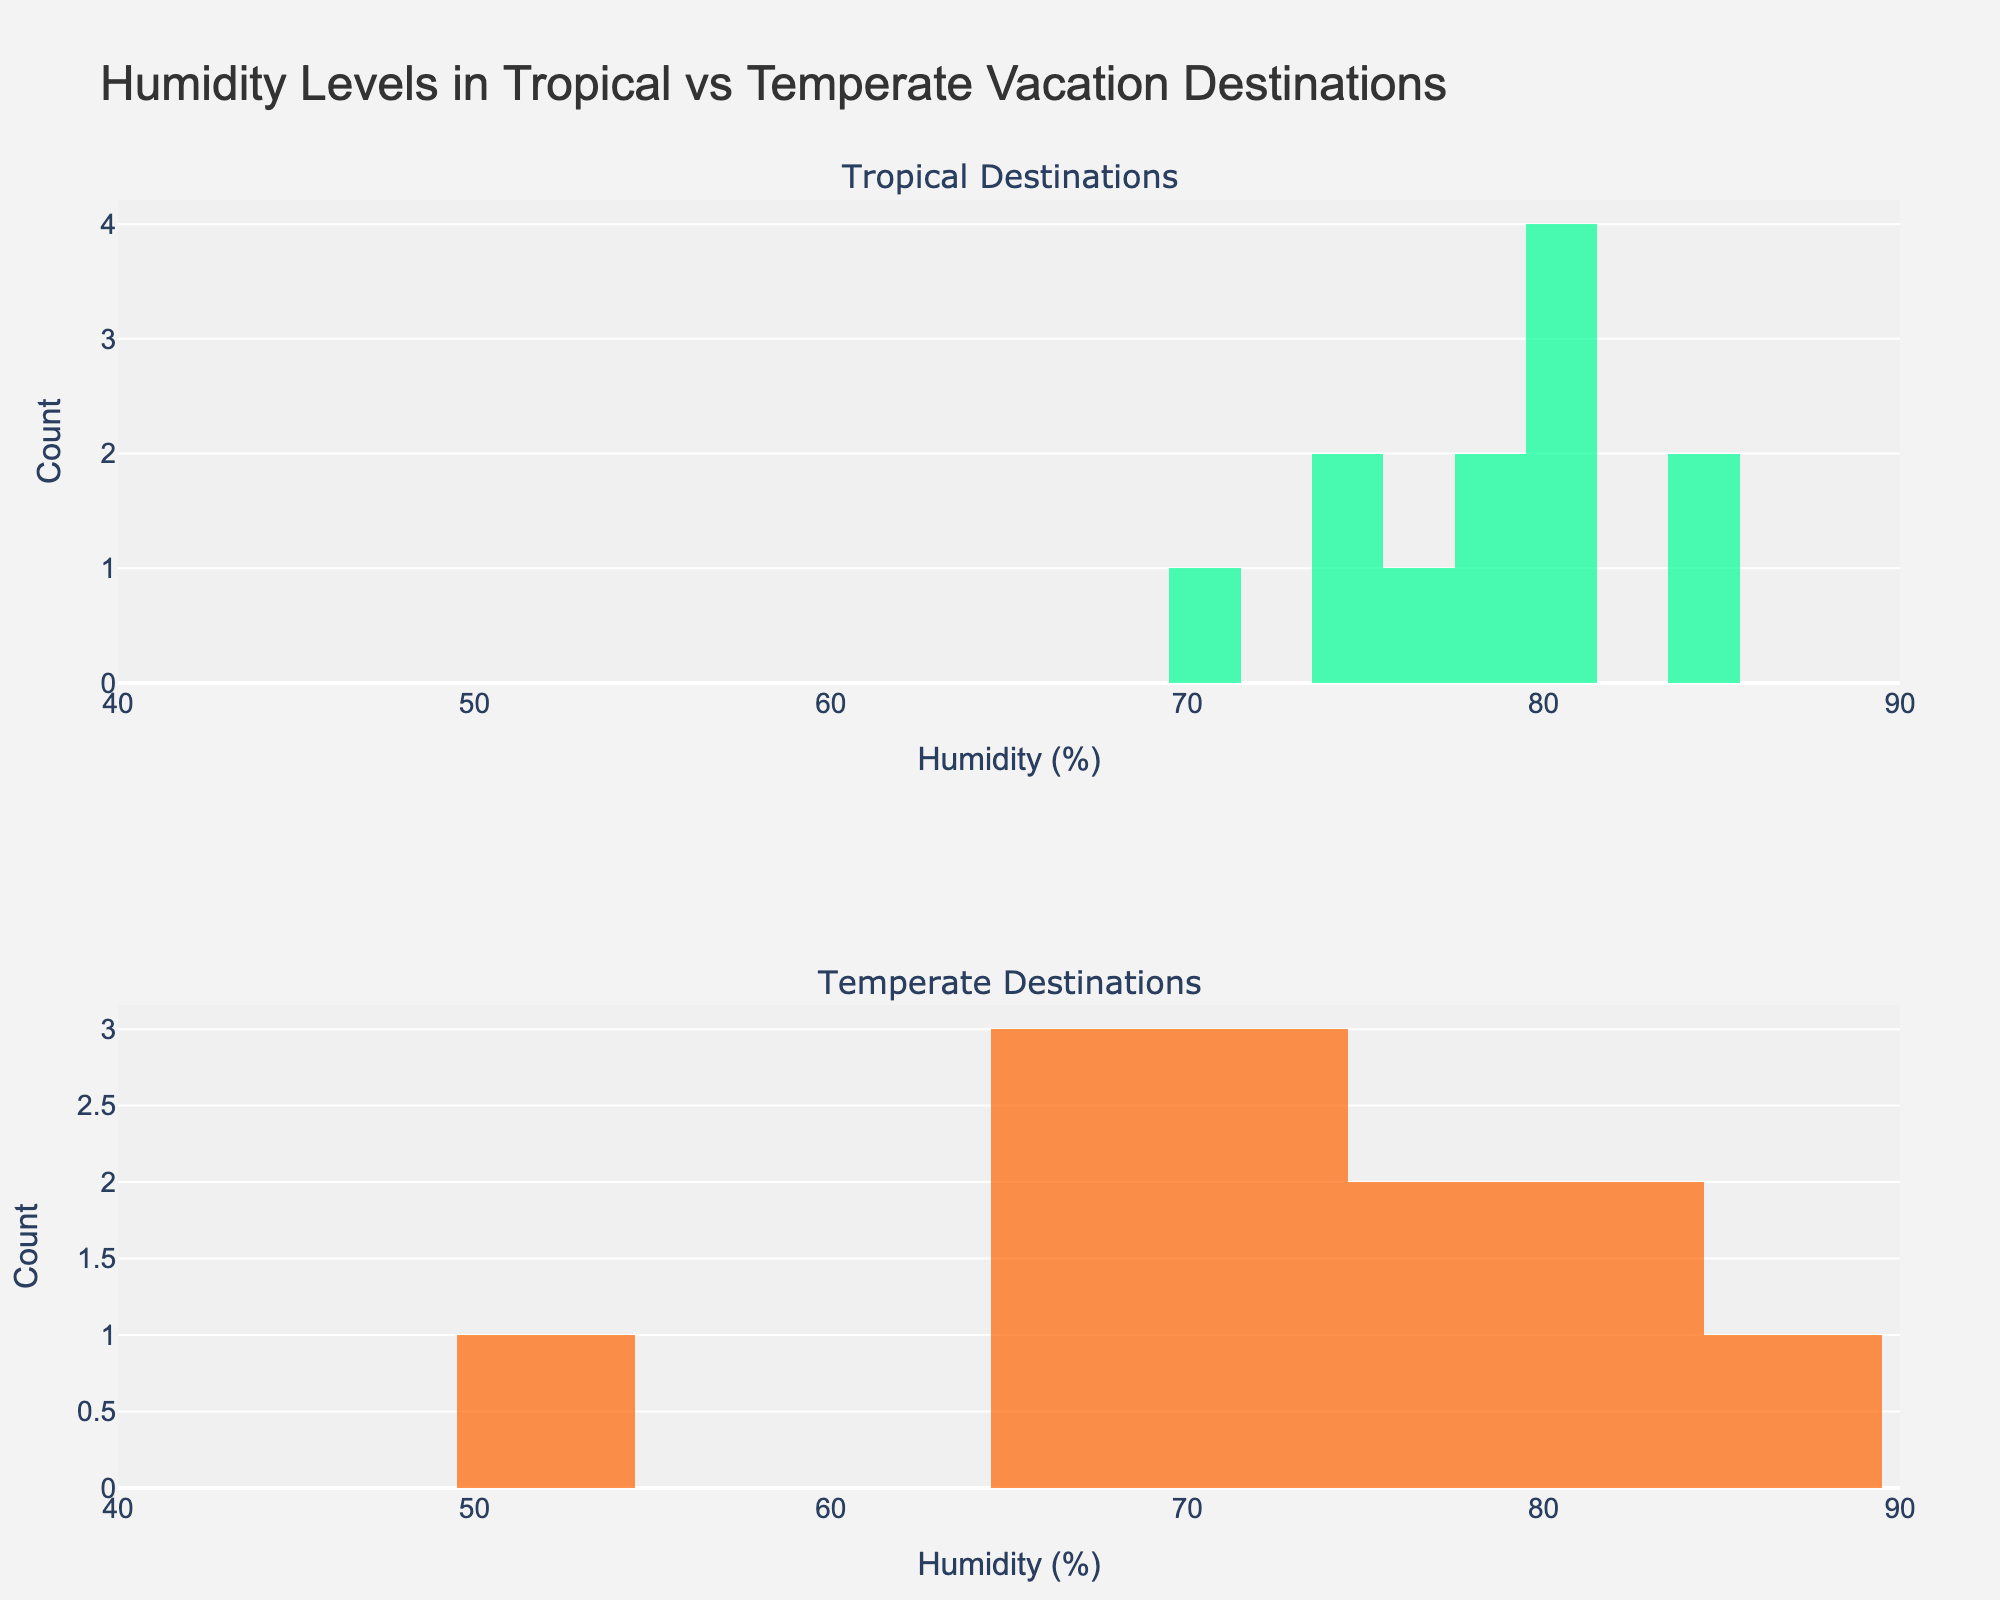What is the title of the figure? The title of the figure is generally displayed prominently at the top and is meant to provide a summary of the content. Here, the title is "Humidity Levels in Tropical vs Temperate Vacation Destinations".
Answer: Humidity Levels in Tropical vs Temperate Vacation Destinations What are the x-axis labels? The x-axis labels are typically found along the bottom of the plot. In this figure, the x-axis labels indicate "Humidity (%)", ranging from 40% to 90% in increments of 10%.
Answer: Humidity (%) What color is used to represent tropical destinations in the histogram? The color used to represent tropical destinations is usually specified in the legend or by visual observation of the bars in the top subplot. In this figure, tropical destinations are represented by a light green color.
Answer: Light green Which month has the highest humidity in tropical destinations? To find the month with the highest humidity in tropical destinations, look at the highest bar in the histogram for tropical destinations. The highest humidity recorded in tropical destinations is 85%, which occurs in January by multiple entries.
Answer: January What's the range of humidity levels in temperate destinations? This can be determined by looking at the histogram for temperate destinations and noting the lowest and highest values along the x-axis. The range is from 50% to 85%.
Answer: 50% to 85% How many months have a humidity level of 70% in temperate destinations? To find this, count the bars in the temperate histogram that align with the x-axis value of 70%. There are three different bars with this humidity value.
Answer: 3 Which climate group shows a wider spread of humidity levels? Compare the spread of the bars along the x-axis for both tropical and temperate groups. The temperate destinations show a wider spread, from 50% to 85%, while tropical destinations range from 70% to 85%.
Answer: Temperate How does the maximum humidity in tropical destinations compare to temperate destinations? Look at the highest bars in both subplots. The maximum humidity is 85% for both tropical and temperate destinations.
Answer: They are equal What’s the total count of months for tropical destinations with a humidity of 80%? Review the number of bars that peak at 80% in the tropical histogram. There are three bars representing this value in April, October for Bali and April for Maldives.
Answer: 3 